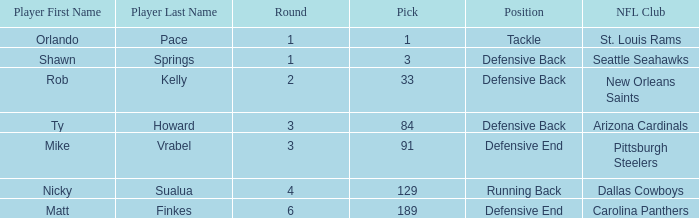What round has a pick less than 189, with arizona cardinals as the NFL club? 3.0. 